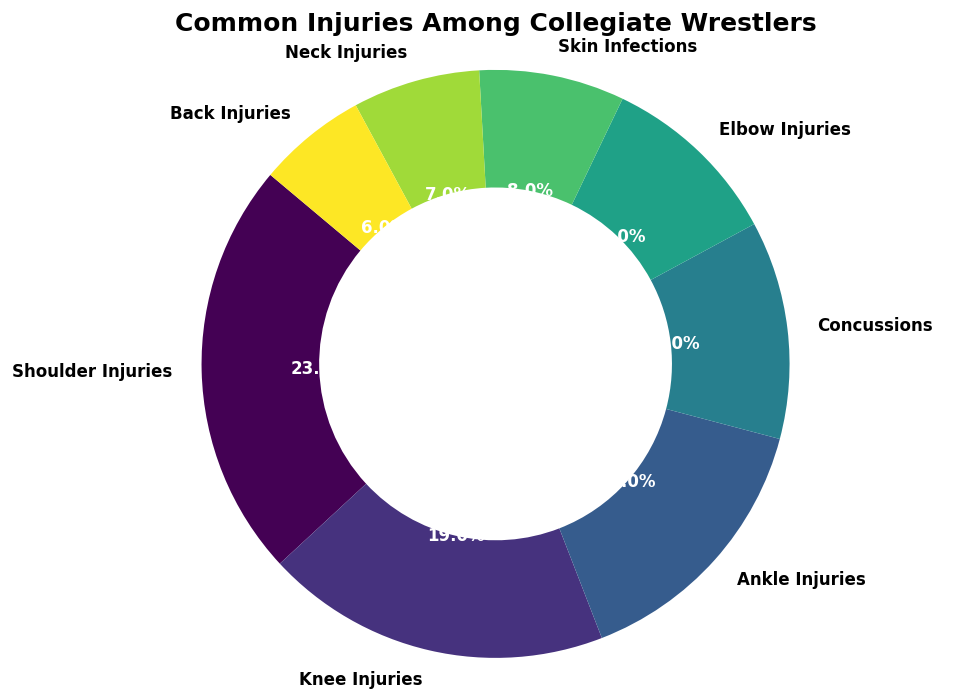Which injury type has the highest proportion? By observing the sizes of the slices in the chart, the largest slice corresponds to Shoulder Injuries.
Answer: Shoulder Injuries What is the total proportion of Knee Injuries and Ankle Injuries combined? Adding the proportions for Knee Injuries (0.19) and Ankle Injuries (0.15), the total is 0.19 + 0.15 = 0.34.
Answer: 0.34 Is the proportion of Concussions greater than the proportion of Elbow Injuries? Comparing the proportions, Concussions (0.12) is greater than Elbow Injuries (0.10).
Answer: Yes Which injuries combined make up more than 50% of the total injuries? Adding the proportions of the major injuries until the sum exceeds 50%: Shoulder Injuries (0.23) + Knee Injuries (0.19) + Ankle Injuries (0.15) sums to 0.57, which is more than 50%.
Answer: Shoulder Injuries, Knee Injuries, and Ankle Injuries What is the difference in proportion between Shoulder Injuries and Neck Injuries? Subtracting the proportion of Neck Injuries (0.07) from Shoulder Injuries (0.23), the difference is 0.23 - 0.07 = 0.16.
Answer: 0.16 Which injury type has the smallest proportion? The smallest slice in the chart corresponds to Back Injuries, with a proportion of 0.06.
Answer: Back Injuries What is the proportion of injuries that are skin-related (Skin Infections)? The proportion for Skin Infections is provided directly in the chart as 0.08.
Answer: 0.08 What is the combined proportion of elbow and neck injuries? Adding the proportions for Elbow Injuries (0.10) and Neck Injuries (0.07), the total is 0.10 + 0.07 = 0.17.
Answer: 0.17 Are there more ankle injuries or back injuries? Comparing the proportions, Ankle Injuries (0.15) are more than Back Injuries (0.06).
Answer: Ankle Injuries 